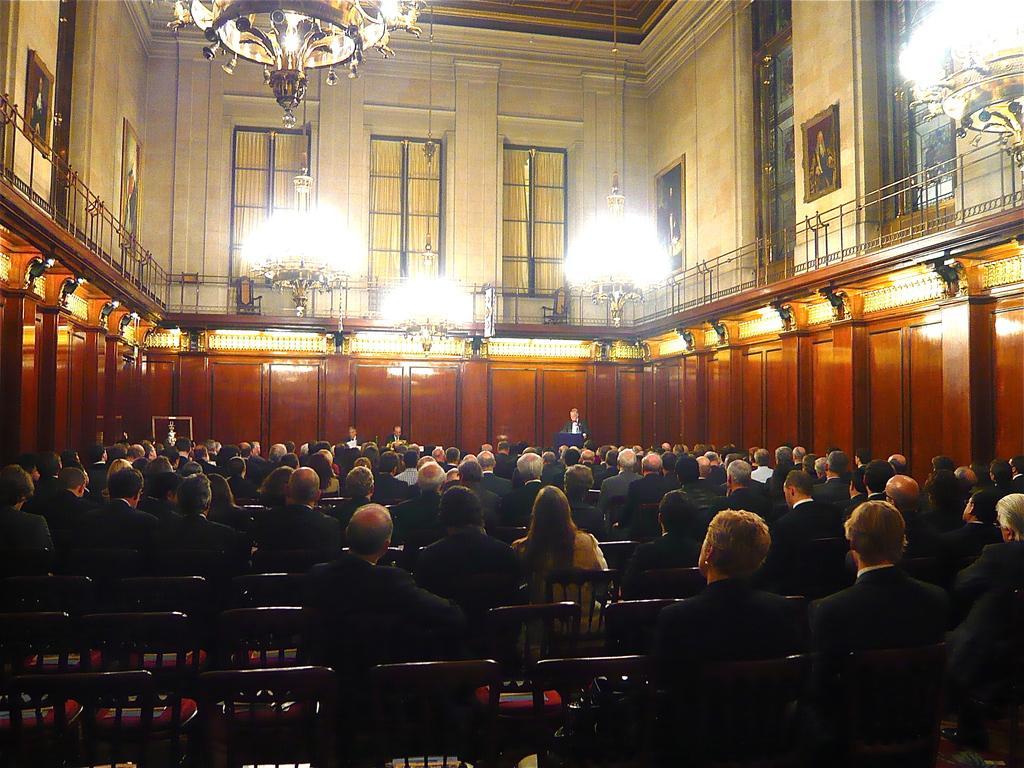Describe this image in one or two sentences. In this image we can see a group of persons are sitting on the chair, here a person is standing, here is the podium, here is the pillar, here is the chandelier, here is the window, here is the wall and a photo frame on it. 